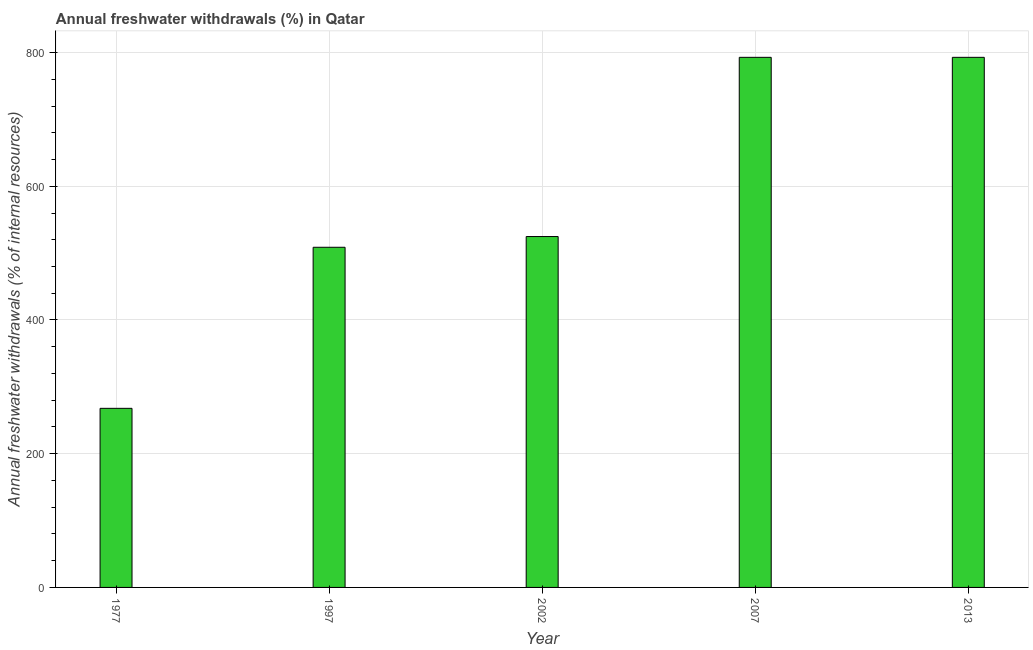Does the graph contain any zero values?
Your response must be concise. No. Does the graph contain grids?
Make the answer very short. Yes. What is the title of the graph?
Keep it short and to the point. Annual freshwater withdrawals (%) in Qatar. What is the label or title of the Y-axis?
Your answer should be compact. Annual freshwater withdrawals (% of internal resources). What is the annual freshwater withdrawals in 1997?
Ensure brevity in your answer.  508.75. Across all years, what is the maximum annual freshwater withdrawals?
Your answer should be very brief. 792.86. Across all years, what is the minimum annual freshwater withdrawals?
Provide a short and direct response. 267.86. What is the sum of the annual freshwater withdrawals?
Your response must be concise. 2887.14. What is the difference between the annual freshwater withdrawals in 1997 and 2007?
Offer a terse response. -284.11. What is the average annual freshwater withdrawals per year?
Offer a terse response. 577.43. What is the median annual freshwater withdrawals?
Keep it short and to the point. 524.82. Do a majority of the years between 1977 and 2013 (inclusive) have annual freshwater withdrawals greater than 600 %?
Ensure brevity in your answer.  No. What is the ratio of the annual freshwater withdrawals in 1997 to that in 2002?
Give a very brief answer. 0.97. Is the annual freshwater withdrawals in 1977 less than that in 2013?
Your response must be concise. Yes. Is the difference between the annual freshwater withdrawals in 1997 and 2002 greater than the difference between any two years?
Keep it short and to the point. No. Is the sum of the annual freshwater withdrawals in 2002 and 2013 greater than the maximum annual freshwater withdrawals across all years?
Provide a short and direct response. Yes. What is the difference between the highest and the lowest annual freshwater withdrawals?
Your response must be concise. 525. What is the Annual freshwater withdrawals (% of internal resources) of 1977?
Provide a succinct answer. 267.86. What is the Annual freshwater withdrawals (% of internal resources) in 1997?
Provide a succinct answer. 508.75. What is the Annual freshwater withdrawals (% of internal resources) of 2002?
Provide a short and direct response. 524.82. What is the Annual freshwater withdrawals (% of internal resources) in 2007?
Your answer should be very brief. 792.86. What is the Annual freshwater withdrawals (% of internal resources) of 2013?
Provide a succinct answer. 792.86. What is the difference between the Annual freshwater withdrawals (% of internal resources) in 1977 and 1997?
Your response must be concise. -240.89. What is the difference between the Annual freshwater withdrawals (% of internal resources) in 1977 and 2002?
Keep it short and to the point. -256.96. What is the difference between the Annual freshwater withdrawals (% of internal resources) in 1977 and 2007?
Give a very brief answer. -525. What is the difference between the Annual freshwater withdrawals (% of internal resources) in 1977 and 2013?
Make the answer very short. -525. What is the difference between the Annual freshwater withdrawals (% of internal resources) in 1997 and 2002?
Keep it short and to the point. -16.07. What is the difference between the Annual freshwater withdrawals (% of internal resources) in 1997 and 2007?
Make the answer very short. -284.11. What is the difference between the Annual freshwater withdrawals (% of internal resources) in 1997 and 2013?
Make the answer very short. -284.11. What is the difference between the Annual freshwater withdrawals (% of internal resources) in 2002 and 2007?
Make the answer very short. -268.04. What is the difference between the Annual freshwater withdrawals (% of internal resources) in 2002 and 2013?
Offer a very short reply. -268.04. What is the difference between the Annual freshwater withdrawals (% of internal resources) in 2007 and 2013?
Provide a succinct answer. 0. What is the ratio of the Annual freshwater withdrawals (% of internal resources) in 1977 to that in 1997?
Make the answer very short. 0.53. What is the ratio of the Annual freshwater withdrawals (% of internal resources) in 1977 to that in 2002?
Your response must be concise. 0.51. What is the ratio of the Annual freshwater withdrawals (% of internal resources) in 1977 to that in 2007?
Your response must be concise. 0.34. What is the ratio of the Annual freshwater withdrawals (% of internal resources) in 1977 to that in 2013?
Ensure brevity in your answer.  0.34. What is the ratio of the Annual freshwater withdrawals (% of internal resources) in 1997 to that in 2002?
Give a very brief answer. 0.97. What is the ratio of the Annual freshwater withdrawals (% of internal resources) in 1997 to that in 2007?
Your answer should be compact. 0.64. What is the ratio of the Annual freshwater withdrawals (% of internal resources) in 1997 to that in 2013?
Your response must be concise. 0.64. What is the ratio of the Annual freshwater withdrawals (% of internal resources) in 2002 to that in 2007?
Your response must be concise. 0.66. What is the ratio of the Annual freshwater withdrawals (% of internal resources) in 2002 to that in 2013?
Make the answer very short. 0.66. What is the ratio of the Annual freshwater withdrawals (% of internal resources) in 2007 to that in 2013?
Your answer should be compact. 1. 